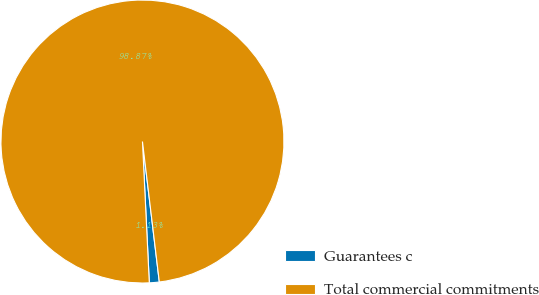Convert chart to OTSL. <chart><loc_0><loc_0><loc_500><loc_500><pie_chart><fcel>Guarantees c<fcel>Total commercial commitments<nl><fcel>1.13%<fcel>98.87%<nl></chart> 